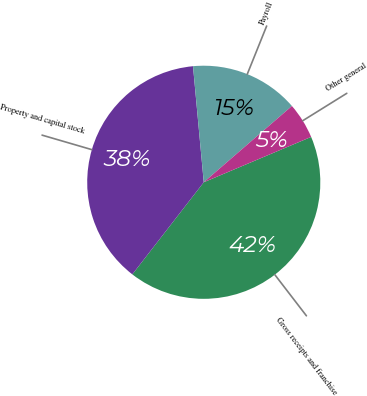Convert chart to OTSL. <chart><loc_0><loc_0><loc_500><loc_500><pie_chart><fcel>Gross receipts and franchise<fcel>Property and capital stock<fcel>Payroll<fcel>Other general<nl><fcel>41.86%<fcel>38.03%<fcel>15.12%<fcel>4.99%<nl></chart> 